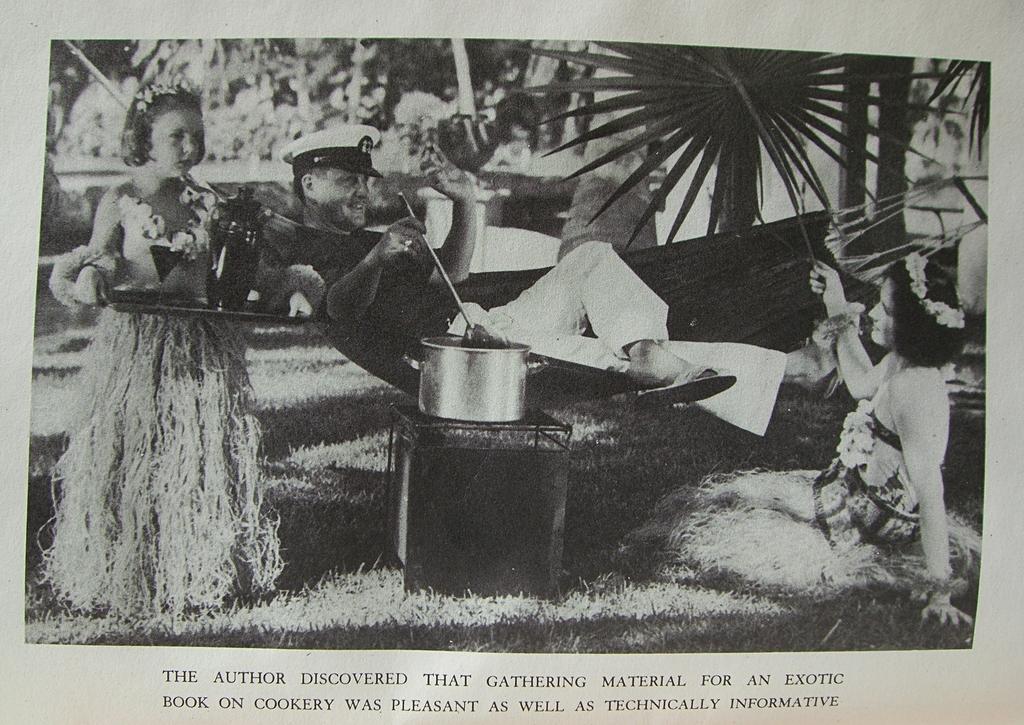How would you summarize this image in a sentence or two? In this image I can see three persons where one is standing, one is lying and one is sitting. On the left side of the image I can see one girl is holding a plate and few other things. In the centre of the image I can see one man is holding, a spoon and in the front of him I can see a table and an utensil on it. In the background I can see number of trees and on the bottom side of the image I can see something is written. I can also see this image is black and white in colour. 